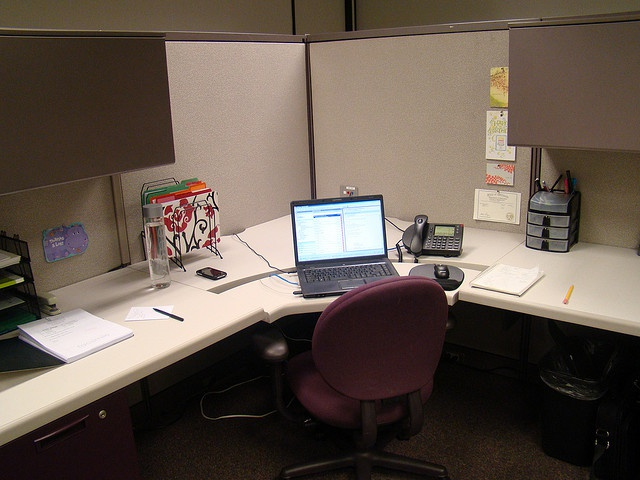Describe the objects in this image and their specific colors. I can see chair in gray, black, maroon, brown, and purple tones, laptop in gray, white, navy, and black tones, bottle in gray and darkgray tones, cell phone in gray, black, and maroon tones, and mouse in gray, black, and darkgray tones in this image. 